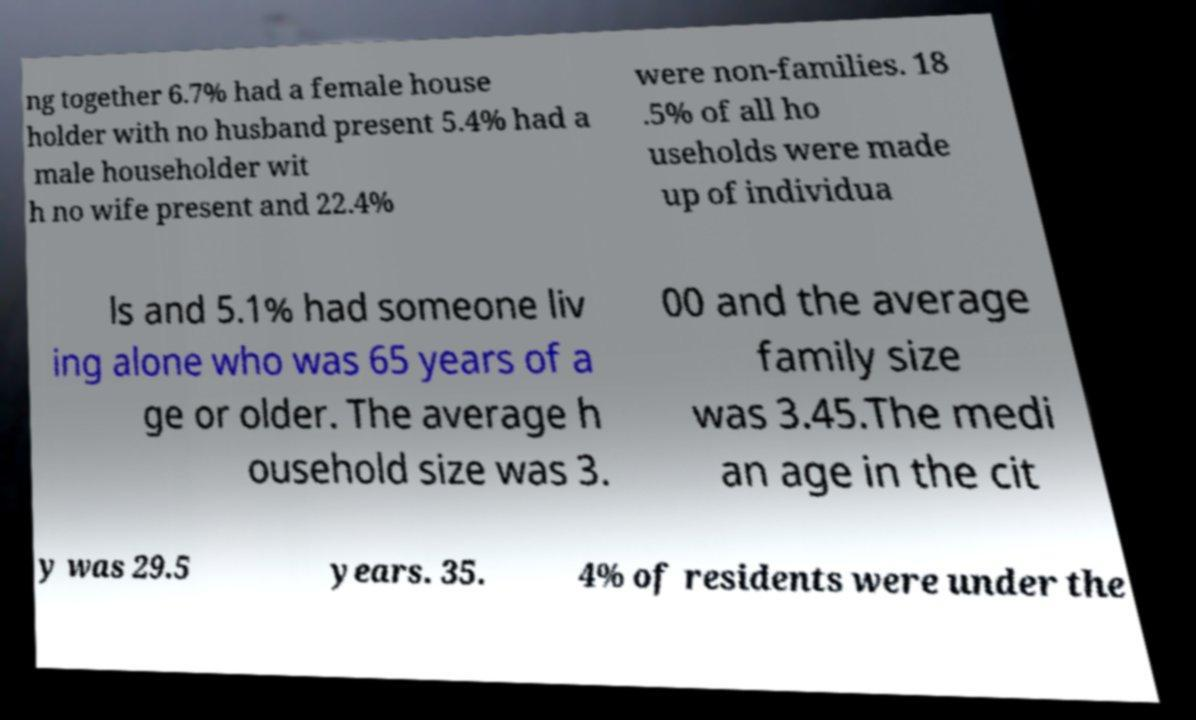For documentation purposes, I need the text within this image transcribed. Could you provide that? ng together 6.7% had a female house holder with no husband present 5.4% had a male householder wit h no wife present and 22.4% were non-families. 18 .5% of all ho useholds were made up of individua ls and 5.1% had someone liv ing alone who was 65 years of a ge or older. The average h ousehold size was 3. 00 and the average family size was 3.45.The medi an age in the cit y was 29.5 years. 35. 4% of residents were under the 